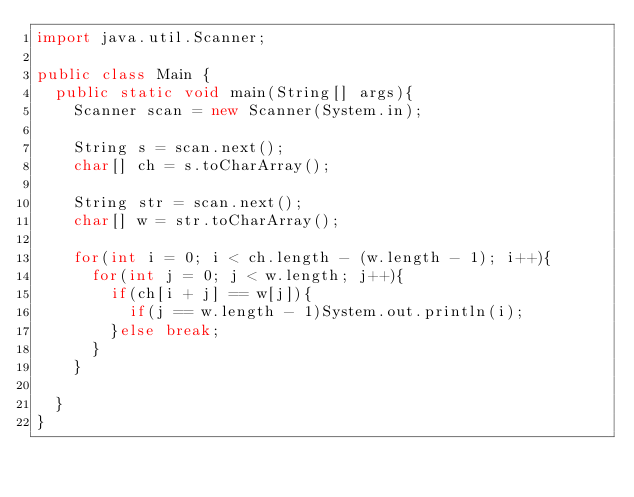<code> <loc_0><loc_0><loc_500><loc_500><_Java_>import java.util.Scanner;

public class Main {
	public static void main(String[] args){
		Scanner scan = new Scanner(System.in);
		
		String s = scan.next();
		char[] ch = s.toCharArray();
		
		String str = scan.next();
		char[] w = str.toCharArray();
		
		for(int i = 0; i < ch.length - (w.length - 1); i++){
			for(int j = 0; j < w.length; j++){
				if(ch[i + j] == w[j]){
					if(j == w.length - 1)System.out.println(i);
				}else break;
			}
		}
		
	}
}</code> 